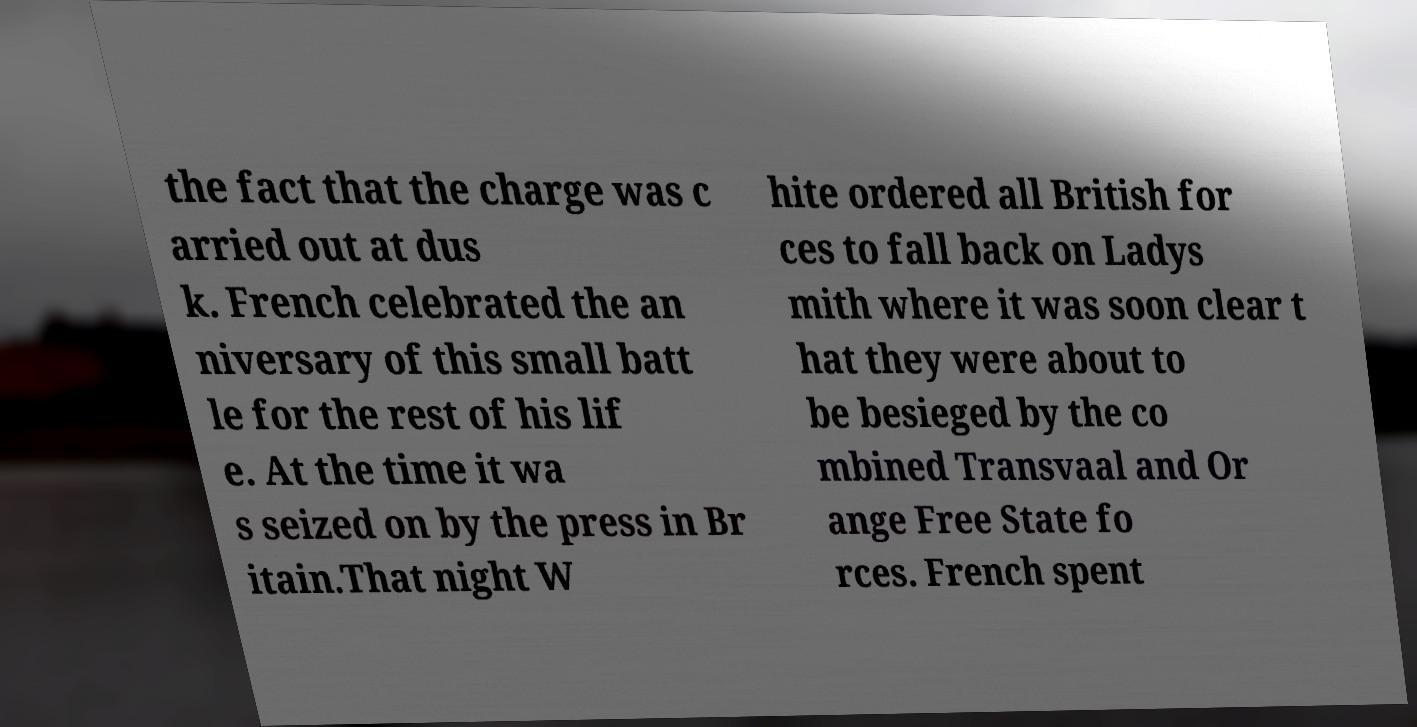I need the written content from this picture converted into text. Can you do that? the fact that the charge was c arried out at dus k. French celebrated the an niversary of this small batt le for the rest of his lif e. At the time it wa s seized on by the press in Br itain.That night W hite ordered all British for ces to fall back on Ladys mith where it was soon clear t hat they were about to be besieged by the co mbined Transvaal and Or ange Free State fo rces. French spent 